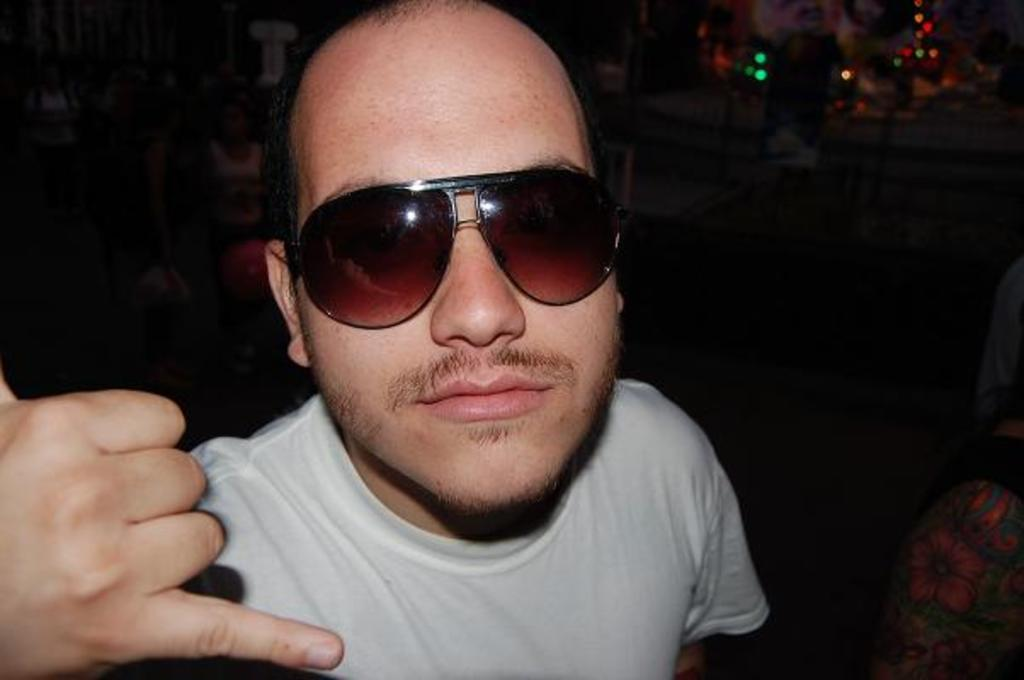What is the overall color scheme of the image? The background of the image is dark. Are there any sources of light visible in the image? Yes, there are a few lights visible in the image. Can you describe the main subject of the image? There is a man in the middle of the image. What type of straw is being used to fly the kite in the image? There is no kite or straw present in the image. Can you recite the verse that is being spoken by the man in the image? There is no verse being spoken by the man in the image. 